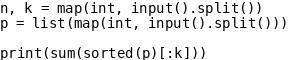<code> <loc_0><loc_0><loc_500><loc_500><_Python_>n, k = map(int, input().split())
p = list(map(int, input().split()))

print(sum(sorted(p)[:k]))</code> 